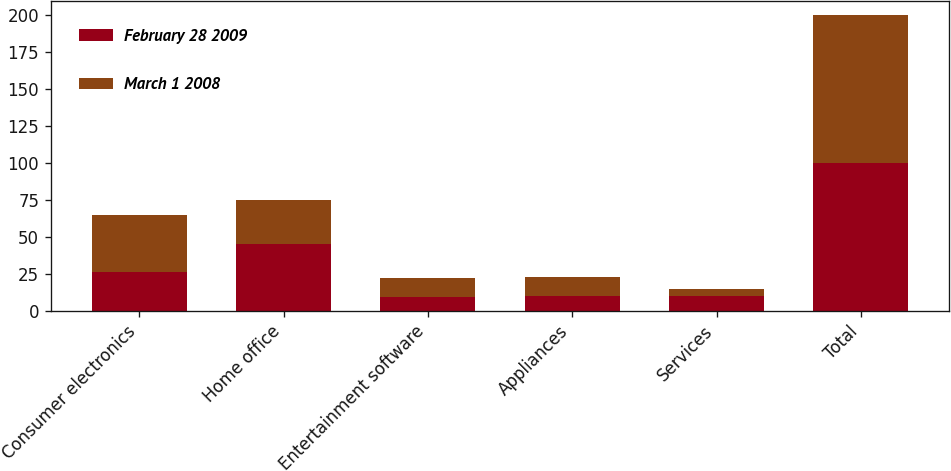<chart> <loc_0><loc_0><loc_500><loc_500><stacked_bar_chart><ecel><fcel>Consumer electronics<fcel>Home office<fcel>Entertainment software<fcel>Appliances<fcel>Services<fcel>Total<nl><fcel>February 28 2009<fcel>26<fcel>45<fcel>9<fcel>10<fcel>10<fcel>100<nl><fcel>March 1 2008<fcel>39<fcel>30<fcel>13<fcel>13<fcel>5<fcel>100<nl></chart> 